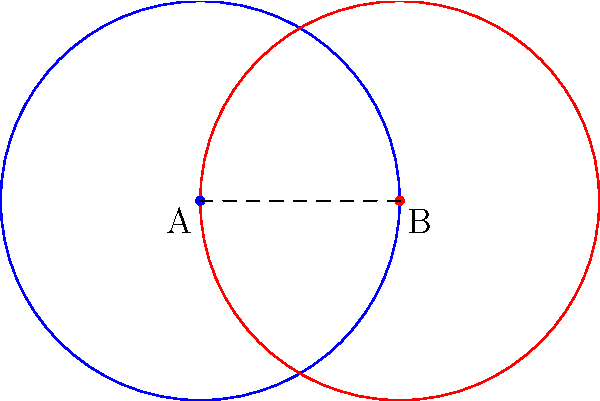In the context of innovative floor layouts, how can a Möbius transformation be applied to create a seamless transition between two circular rooms represented by the blue and red circles? Describe the transformation and its effect on the floor plan. To apply a Möbius transformation to create a seamless transition between two circular rooms, we can follow these steps:

1. Identify the two circular rooms: In the diagram, we have two circles representing rooms A (blue) and B (red).

2. Choose a Möbius transformation: We'll use the inversion with respect to the unit circle centered at the point of intersection of the two circles.

3. Apply the transformation:
   a) The blue circle (A) will be mapped to a straight line.
   b) The red circle (B) will remain a circle but will be modified.

4. Interpret the result:
   a) The straight line represents an infinitely long corridor connecting the two rooms.
   b) The transformed red circle represents the modified shape of room B.

5. Architectural implications:
   a) The seamless transition creates a continuous flow between the spaces.
   b) The corridor can be seen as a gradual morphing of room A into room B.

6. Design considerations:
   a) The transformation preserves angles, maintaining the relative orientation of features within each room.
   b) Distances are distorted, which can be used to create interesting spatial experiences.

The resulting floor plan would feature a smooth transition from a circular room (A) through a corridor that gradually transforms into another circular room (B), creating a unique and innovative spatial experience.
Answer: Inversion transformation at intersection point: circular room A becomes a corridor, seamlessly transitioning into modified circular room B. 